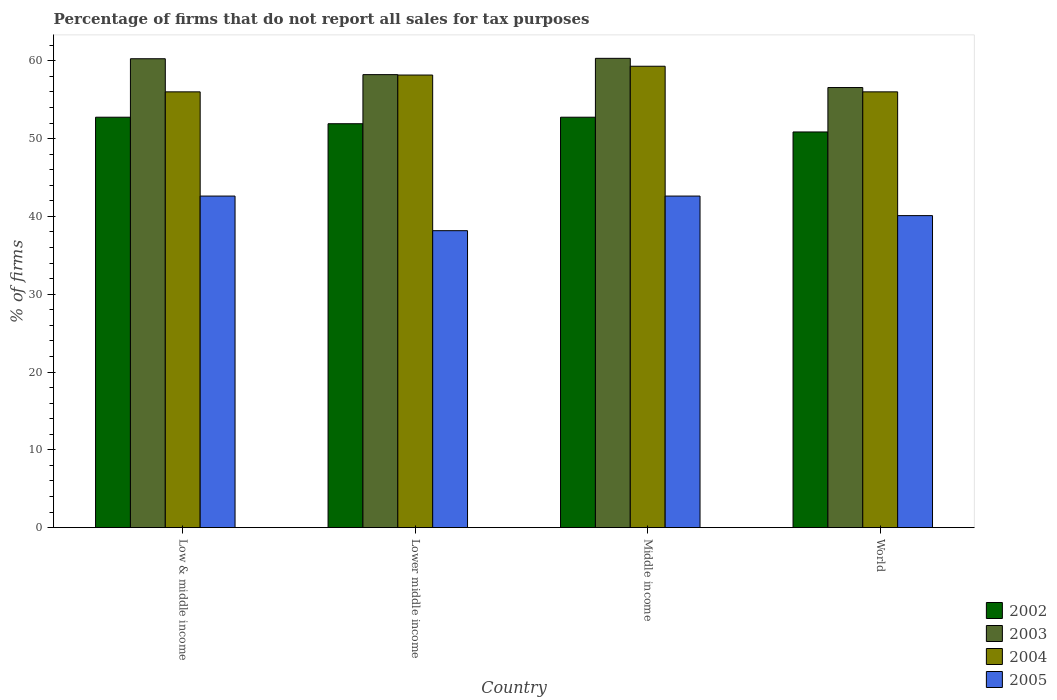How many different coloured bars are there?
Provide a succinct answer. 4. Are the number of bars on each tick of the X-axis equal?
Provide a succinct answer. Yes. How many bars are there on the 1st tick from the left?
Your response must be concise. 4. How many bars are there on the 3rd tick from the right?
Your answer should be very brief. 4. What is the label of the 2nd group of bars from the left?
Ensure brevity in your answer.  Lower middle income. What is the percentage of firms that do not report all sales for tax purposes in 2002 in Lower middle income?
Provide a short and direct response. 51.91. Across all countries, what is the maximum percentage of firms that do not report all sales for tax purposes in 2005?
Ensure brevity in your answer.  42.61. Across all countries, what is the minimum percentage of firms that do not report all sales for tax purposes in 2002?
Your answer should be compact. 50.85. What is the total percentage of firms that do not report all sales for tax purposes in 2005 in the graph?
Your response must be concise. 163.48. What is the difference between the percentage of firms that do not report all sales for tax purposes in 2003 in Low & middle income and that in Lower middle income?
Provide a succinct answer. 2.04. What is the difference between the percentage of firms that do not report all sales for tax purposes in 2002 in Low & middle income and the percentage of firms that do not report all sales for tax purposes in 2005 in Middle income?
Your response must be concise. 10.13. What is the average percentage of firms that do not report all sales for tax purposes in 2003 per country?
Give a very brief answer. 58.84. What is the difference between the percentage of firms that do not report all sales for tax purposes of/in 2004 and percentage of firms that do not report all sales for tax purposes of/in 2005 in Low & middle income?
Give a very brief answer. 13.39. In how many countries, is the percentage of firms that do not report all sales for tax purposes in 2003 greater than 14 %?
Provide a succinct answer. 4. What is the ratio of the percentage of firms that do not report all sales for tax purposes in 2004 in Low & middle income to that in Middle income?
Give a very brief answer. 0.94. Is the difference between the percentage of firms that do not report all sales for tax purposes in 2004 in Lower middle income and World greater than the difference between the percentage of firms that do not report all sales for tax purposes in 2005 in Lower middle income and World?
Your response must be concise. Yes. What is the difference between the highest and the second highest percentage of firms that do not report all sales for tax purposes in 2002?
Provide a short and direct response. -0.84. What is the difference between the highest and the lowest percentage of firms that do not report all sales for tax purposes in 2004?
Offer a very short reply. 3.29. In how many countries, is the percentage of firms that do not report all sales for tax purposes in 2002 greater than the average percentage of firms that do not report all sales for tax purposes in 2002 taken over all countries?
Keep it short and to the point. 2. Is the sum of the percentage of firms that do not report all sales for tax purposes in 2005 in Low & middle income and Lower middle income greater than the maximum percentage of firms that do not report all sales for tax purposes in 2003 across all countries?
Ensure brevity in your answer.  Yes. Is it the case that in every country, the sum of the percentage of firms that do not report all sales for tax purposes in 2002 and percentage of firms that do not report all sales for tax purposes in 2005 is greater than the sum of percentage of firms that do not report all sales for tax purposes in 2003 and percentage of firms that do not report all sales for tax purposes in 2004?
Your answer should be compact. Yes. What does the 2nd bar from the left in Lower middle income represents?
Make the answer very short. 2003. What does the 1st bar from the right in Lower middle income represents?
Your answer should be compact. 2005. Is it the case that in every country, the sum of the percentage of firms that do not report all sales for tax purposes in 2004 and percentage of firms that do not report all sales for tax purposes in 2002 is greater than the percentage of firms that do not report all sales for tax purposes in 2005?
Ensure brevity in your answer.  Yes. How many bars are there?
Ensure brevity in your answer.  16. How many countries are there in the graph?
Keep it short and to the point. 4. Where does the legend appear in the graph?
Your answer should be compact. Bottom right. What is the title of the graph?
Your answer should be compact. Percentage of firms that do not report all sales for tax purposes. What is the label or title of the X-axis?
Provide a short and direct response. Country. What is the label or title of the Y-axis?
Offer a very short reply. % of firms. What is the % of firms in 2002 in Low & middle income?
Your answer should be very brief. 52.75. What is the % of firms in 2003 in Low & middle income?
Your response must be concise. 60.26. What is the % of firms of 2004 in Low & middle income?
Make the answer very short. 56.01. What is the % of firms of 2005 in Low & middle income?
Your response must be concise. 42.61. What is the % of firms in 2002 in Lower middle income?
Provide a succinct answer. 51.91. What is the % of firms in 2003 in Lower middle income?
Provide a succinct answer. 58.22. What is the % of firms in 2004 in Lower middle income?
Ensure brevity in your answer.  58.16. What is the % of firms in 2005 in Lower middle income?
Provide a short and direct response. 38.16. What is the % of firms of 2002 in Middle income?
Provide a succinct answer. 52.75. What is the % of firms in 2003 in Middle income?
Offer a very short reply. 60.31. What is the % of firms of 2004 in Middle income?
Provide a short and direct response. 59.3. What is the % of firms in 2005 in Middle income?
Offer a terse response. 42.61. What is the % of firms of 2002 in World?
Your answer should be very brief. 50.85. What is the % of firms of 2003 in World?
Give a very brief answer. 56.56. What is the % of firms in 2004 in World?
Make the answer very short. 56.01. What is the % of firms in 2005 in World?
Your answer should be compact. 40.1. Across all countries, what is the maximum % of firms in 2002?
Offer a terse response. 52.75. Across all countries, what is the maximum % of firms in 2003?
Offer a terse response. 60.31. Across all countries, what is the maximum % of firms in 2004?
Offer a terse response. 59.3. Across all countries, what is the maximum % of firms of 2005?
Make the answer very short. 42.61. Across all countries, what is the minimum % of firms of 2002?
Offer a very short reply. 50.85. Across all countries, what is the minimum % of firms of 2003?
Your answer should be compact. 56.56. Across all countries, what is the minimum % of firms of 2004?
Make the answer very short. 56.01. Across all countries, what is the minimum % of firms of 2005?
Keep it short and to the point. 38.16. What is the total % of firms of 2002 in the graph?
Provide a short and direct response. 208.25. What is the total % of firms in 2003 in the graph?
Provide a short and direct response. 235.35. What is the total % of firms in 2004 in the graph?
Your answer should be very brief. 229.47. What is the total % of firms of 2005 in the graph?
Give a very brief answer. 163.48. What is the difference between the % of firms of 2002 in Low & middle income and that in Lower middle income?
Offer a terse response. 0.84. What is the difference between the % of firms in 2003 in Low & middle income and that in Lower middle income?
Your answer should be very brief. 2.04. What is the difference between the % of firms in 2004 in Low & middle income and that in Lower middle income?
Your answer should be very brief. -2.16. What is the difference between the % of firms of 2005 in Low & middle income and that in Lower middle income?
Make the answer very short. 4.45. What is the difference between the % of firms in 2003 in Low & middle income and that in Middle income?
Make the answer very short. -0.05. What is the difference between the % of firms in 2004 in Low & middle income and that in Middle income?
Ensure brevity in your answer.  -3.29. What is the difference between the % of firms in 2002 in Low & middle income and that in World?
Keep it short and to the point. 1.89. What is the difference between the % of firms in 2004 in Low & middle income and that in World?
Your answer should be compact. 0. What is the difference between the % of firms in 2005 in Low & middle income and that in World?
Your answer should be very brief. 2.51. What is the difference between the % of firms of 2002 in Lower middle income and that in Middle income?
Provide a short and direct response. -0.84. What is the difference between the % of firms in 2003 in Lower middle income and that in Middle income?
Offer a terse response. -2.09. What is the difference between the % of firms in 2004 in Lower middle income and that in Middle income?
Your response must be concise. -1.13. What is the difference between the % of firms in 2005 in Lower middle income and that in Middle income?
Offer a very short reply. -4.45. What is the difference between the % of firms in 2002 in Lower middle income and that in World?
Your answer should be very brief. 1.06. What is the difference between the % of firms of 2003 in Lower middle income and that in World?
Offer a terse response. 1.66. What is the difference between the % of firms in 2004 in Lower middle income and that in World?
Make the answer very short. 2.16. What is the difference between the % of firms of 2005 in Lower middle income and that in World?
Your answer should be compact. -1.94. What is the difference between the % of firms in 2002 in Middle income and that in World?
Ensure brevity in your answer.  1.89. What is the difference between the % of firms of 2003 in Middle income and that in World?
Make the answer very short. 3.75. What is the difference between the % of firms in 2004 in Middle income and that in World?
Keep it short and to the point. 3.29. What is the difference between the % of firms in 2005 in Middle income and that in World?
Provide a short and direct response. 2.51. What is the difference between the % of firms of 2002 in Low & middle income and the % of firms of 2003 in Lower middle income?
Keep it short and to the point. -5.47. What is the difference between the % of firms in 2002 in Low & middle income and the % of firms in 2004 in Lower middle income?
Make the answer very short. -5.42. What is the difference between the % of firms in 2002 in Low & middle income and the % of firms in 2005 in Lower middle income?
Provide a succinct answer. 14.58. What is the difference between the % of firms in 2003 in Low & middle income and the % of firms in 2004 in Lower middle income?
Offer a very short reply. 2.1. What is the difference between the % of firms in 2003 in Low & middle income and the % of firms in 2005 in Lower middle income?
Your answer should be compact. 22.1. What is the difference between the % of firms of 2004 in Low & middle income and the % of firms of 2005 in Lower middle income?
Provide a succinct answer. 17.84. What is the difference between the % of firms in 2002 in Low & middle income and the % of firms in 2003 in Middle income?
Provide a succinct answer. -7.57. What is the difference between the % of firms in 2002 in Low & middle income and the % of firms in 2004 in Middle income?
Your answer should be very brief. -6.55. What is the difference between the % of firms of 2002 in Low & middle income and the % of firms of 2005 in Middle income?
Keep it short and to the point. 10.13. What is the difference between the % of firms in 2003 in Low & middle income and the % of firms in 2005 in Middle income?
Your answer should be compact. 17.65. What is the difference between the % of firms in 2004 in Low & middle income and the % of firms in 2005 in Middle income?
Keep it short and to the point. 13.39. What is the difference between the % of firms in 2002 in Low & middle income and the % of firms in 2003 in World?
Keep it short and to the point. -3.81. What is the difference between the % of firms of 2002 in Low & middle income and the % of firms of 2004 in World?
Your answer should be compact. -3.26. What is the difference between the % of firms in 2002 in Low & middle income and the % of firms in 2005 in World?
Make the answer very short. 12.65. What is the difference between the % of firms of 2003 in Low & middle income and the % of firms of 2004 in World?
Provide a short and direct response. 4.25. What is the difference between the % of firms in 2003 in Low & middle income and the % of firms in 2005 in World?
Ensure brevity in your answer.  20.16. What is the difference between the % of firms in 2004 in Low & middle income and the % of firms in 2005 in World?
Give a very brief answer. 15.91. What is the difference between the % of firms in 2002 in Lower middle income and the % of firms in 2003 in Middle income?
Provide a succinct answer. -8.4. What is the difference between the % of firms in 2002 in Lower middle income and the % of firms in 2004 in Middle income?
Give a very brief answer. -7.39. What is the difference between the % of firms in 2002 in Lower middle income and the % of firms in 2005 in Middle income?
Your answer should be compact. 9.3. What is the difference between the % of firms in 2003 in Lower middle income and the % of firms in 2004 in Middle income?
Your answer should be very brief. -1.08. What is the difference between the % of firms of 2003 in Lower middle income and the % of firms of 2005 in Middle income?
Keep it short and to the point. 15.61. What is the difference between the % of firms in 2004 in Lower middle income and the % of firms in 2005 in Middle income?
Provide a short and direct response. 15.55. What is the difference between the % of firms in 2002 in Lower middle income and the % of firms in 2003 in World?
Your answer should be very brief. -4.65. What is the difference between the % of firms of 2002 in Lower middle income and the % of firms of 2004 in World?
Give a very brief answer. -4.1. What is the difference between the % of firms of 2002 in Lower middle income and the % of firms of 2005 in World?
Give a very brief answer. 11.81. What is the difference between the % of firms in 2003 in Lower middle income and the % of firms in 2004 in World?
Give a very brief answer. 2.21. What is the difference between the % of firms of 2003 in Lower middle income and the % of firms of 2005 in World?
Provide a succinct answer. 18.12. What is the difference between the % of firms in 2004 in Lower middle income and the % of firms in 2005 in World?
Your answer should be very brief. 18.07. What is the difference between the % of firms in 2002 in Middle income and the % of firms in 2003 in World?
Offer a very short reply. -3.81. What is the difference between the % of firms of 2002 in Middle income and the % of firms of 2004 in World?
Provide a succinct answer. -3.26. What is the difference between the % of firms of 2002 in Middle income and the % of firms of 2005 in World?
Provide a succinct answer. 12.65. What is the difference between the % of firms in 2003 in Middle income and the % of firms in 2004 in World?
Make the answer very short. 4.31. What is the difference between the % of firms in 2003 in Middle income and the % of firms in 2005 in World?
Your answer should be very brief. 20.21. What is the difference between the % of firms in 2004 in Middle income and the % of firms in 2005 in World?
Make the answer very short. 19.2. What is the average % of firms in 2002 per country?
Keep it short and to the point. 52.06. What is the average % of firms of 2003 per country?
Provide a short and direct response. 58.84. What is the average % of firms of 2004 per country?
Provide a succinct answer. 57.37. What is the average % of firms in 2005 per country?
Make the answer very short. 40.87. What is the difference between the % of firms in 2002 and % of firms in 2003 in Low & middle income?
Your answer should be very brief. -7.51. What is the difference between the % of firms in 2002 and % of firms in 2004 in Low & middle income?
Keep it short and to the point. -3.26. What is the difference between the % of firms of 2002 and % of firms of 2005 in Low & middle income?
Give a very brief answer. 10.13. What is the difference between the % of firms of 2003 and % of firms of 2004 in Low & middle income?
Provide a succinct answer. 4.25. What is the difference between the % of firms in 2003 and % of firms in 2005 in Low & middle income?
Your response must be concise. 17.65. What is the difference between the % of firms of 2004 and % of firms of 2005 in Low & middle income?
Your response must be concise. 13.39. What is the difference between the % of firms in 2002 and % of firms in 2003 in Lower middle income?
Your response must be concise. -6.31. What is the difference between the % of firms in 2002 and % of firms in 2004 in Lower middle income?
Your answer should be compact. -6.26. What is the difference between the % of firms of 2002 and % of firms of 2005 in Lower middle income?
Offer a terse response. 13.75. What is the difference between the % of firms in 2003 and % of firms in 2004 in Lower middle income?
Give a very brief answer. 0.05. What is the difference between the % of firms of 2003 and % of firms of 2005 in Lower middle income?
Your answer should be compact. 20.06. What is the difference between the % of firms of 2004 and % of firms of 2005 in Lower middle income?
Ensure brevity in your answer.  20. What is the difference between the % of firms of 2002 and % of firms of 2003 in Middle income?
Your answer should be compact. -7.57. What is the difference between the % of firms in 2002 and % of firms in 2004 in Middle income?
Provide a succinct answer. -6.55. What is the difference between the % of firms in 2002 and % of firms in 2005 in Middle income?
Offer a terse response. 10.13. What is the difference between the % of firms of 2003 and % of firms of 2004 in Middle income?
Keep it short and to the point. 1.02. What is the difference between the % of firms of 2003 and % of firms of 2005 in Middle income?
Make the answer very short. 17.7. What is the difference between the % of firms of 2004 and % of firms of 2005 in Middle income?
Your response must be concise. 16.69. What is the difference between the % of firms of 2002 and % of firms of 2003 in World?
Your response must be concise. -5.71. What is the difference between the % of firms in 2002 and % of firms in 2004 in World?
Offer a very short reply. -5.15. What is the difference between the % of firms in 2002 and % of firms in 2005 in World?
Give a very brief answer. 10.75. What is the difference between the % of firms of 2003 and % of firms of 2004 in World?
Offer a very short reply. 0.56. What is the difference between the % of firms of 2003 and % of firms of 2005 in World?
Your answer should be compact. 16.46. What is the difference between the % of firms in 2004 and % of firms in 2005 in World?
Provide a short and direct response. 15.91. What is the ratio of the % of firms of 2002 in Low & middle income to that in Lower middle income?
Your answer should be compact. 1.02. What is the ratio of the % of firms of 2003 in Low & middle income to that in Lower middle income?
Your response must be concise. 1.04. What is the ratio of the % of firms of 2004 in Low & middle income to that in Lower middle income?
Offer a very short reply. 0.96. What is the ratio of the % of firms in 2005 in Low & middle income to that in Lower middle income?
Your answer should be compact. 1.12. What is the ratio of the % of firms in 2004 in Low & middle income to that in Middle income?
Ensure brevity in your answer.  0.94. What is the ratio of the % of firms in 2005 in Low & middle income to that in Middle income?
Ensure brevity in your answer.  1. What is the ratio of the % of firms in 2002 in Low & middle income to that in World?
Keep it short and to the point. 1.04. What is the ratio of the % of firms in 2003 in Low & middle income to that in World?
Your response must be concise. 1.07. What is the ratio of the % of firms in 2004 in Low & middle income to that in World?
Your answer should be compact. 1. What is the ratio of the % of firms of 2005 in Low & middle income to that in World?
Provide a short and direct response. 1.06. What is the ratio of the % of firms of 2002 in Lower middle income to that in Middle income?
Your response must be concise. 0.98. What is the ratio of the % of firms in 2003 in Lower middle income to that in Middle income?
Keep it short and to the point. 0.97. What is the ratio of the % of firms of 2004 in Lower middle income to that in Middle income?
Keep it short and to the point. 0.98. What is the ratio of the % of firms in 2005 in Lower middle income to that in Middle income?
Ensure brevity in your answer.  0.9. What is the ratio of the % of firms of 2002 in Lower middle income to that in World?
Give a very brief answer. 1.02. What is the ratio of the % of firms of 2003 in Lower middle income to that in World?
Your answer should be very brief. 1.03. What is the ratio of the % of firms of 2004 in Lower middle income to that in World?
Make the answer very short. 1.04. What is the ratio of the % of firms of 2005 in Lower middle income to that in World?
Provide a short and direct response. 0.95. What is the ratio of the % of firms of 2002 in Middle income to that in World?
Provide a succinct answer. 1.04. What is the ratio of the % of firms in 2003 in Middle income to that in World?
Provide a short and direct response. 1.07. What is the ratio of the % of firms in 2004 in Middle income to that in World?
Your response must be concise. 1.06. What is the ratio of the % of firms in 2005 in Middle income to that in World?
Offer a very short reply. 1.06. What is the difference between the highest and the second highest % of firms of 2003?
Your response must be concise. 0.05. What is the difference between the highest and the second highest % of firms in 2004?
Keep it short and to the point. 1.13. What is the difference between the highest and the second highest % of firms of 2005?
Ensure brevity in your answer.  0. What is the difference between the highest and the lowest % of firms in 2002?
Give a very brief answer. 1.89. What is the difference between the highest and the lowest % of firms of 2003?
Ensure brevity in your answer.  3.75. What is the difference between the highest and the lowest % of firms in 2004?
Give a very brief answer. 3.29. What is the difference between the highest and the lowest % of firms in 2005?
Provide a short and direct response. 4.45. 